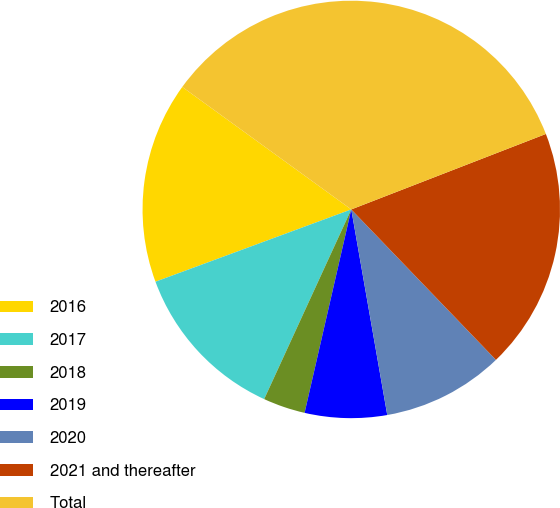Convert chart to OTSL. <chart><loc_0><loc_0><loc_500><loc_500><pie_chart><fcel>2016<fcel>2017<fcel>2018<fcel>2019<fcel>2020<fcel>2021 and thereafter<fcel>Total<nl><fcel>15.61%<fcel>12.52%<fcel>3.26%<fcel>6.35%<fcel>9.43%<fcel>18.7%<fcel>34.13%<nl></chart> 